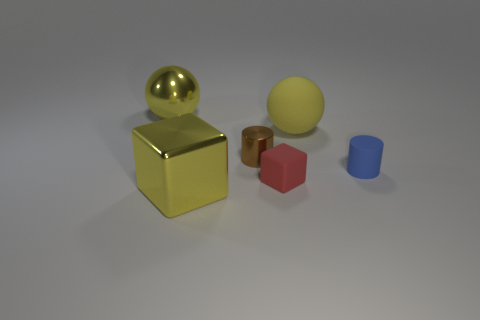The shiny thing that is the same color as the metallic sphere is what shape?
Offer a very short reply. Cube. What number of blue rubber cylinders have the same size as the matte cube?
Provide a succinct answer. 1. What is the size of the metallic thing that is the same color as the large block?
Ensure brevity in your answer.  Large. How many things are big objects or shiny objects that are behind the matte sphere?
Provide a succinct answer. 3. What color is the object that is to the left of the small matte block and right of the yellow shiny cube?
Offer a very short reply. Brown. Is the blue rubber cylinder the same size as the metallic ball?
Your answer should be compact. No. What color is the object that is in front of the red thing?
Keep it short and to the point. Yellow. Is there a small matte cube that has the same color as the tiny metal object?
Provide a succinct answer. No. What is the color of the cube that is the same size as the shiny cylinder?
Ensure brevity in your answer.  Red. Is the big yellow rubber thing the same shape as the small red thing?
Offer a terse response. No. 